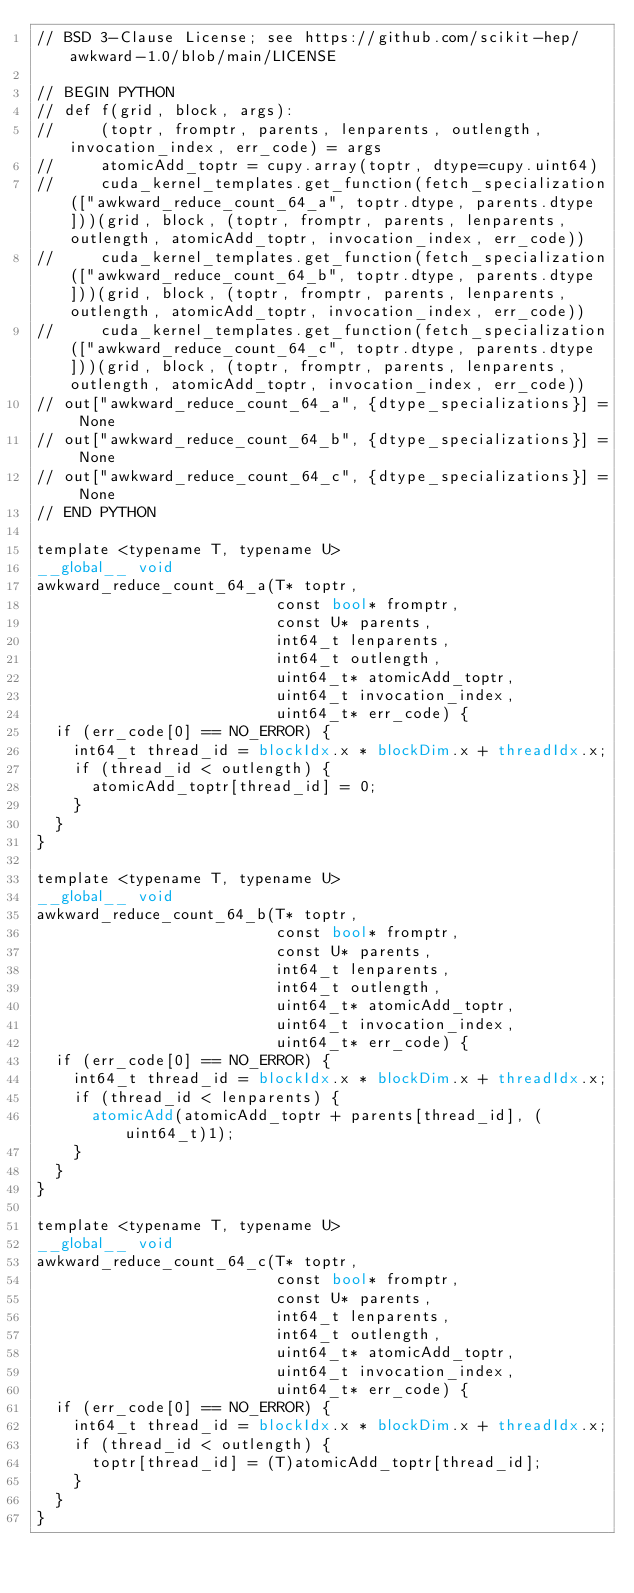Convert code to text. <code><loc_0><loc_0><loc_500><loc_500><_Cuda_>// BSD 3-Clause License; see https://github.com/scikit-hep/awkward-1.0/blob/main/LICENSE

// BEGIN PYTHON
// def f(grid, block, args):
//     (toptr, fromptr, parents, lenparents, outlength, invocation_index, err_code) = args
//     atomicAdd_toptr = cupy.array(toptr, dtype=cupy.uint64)
//     cuda_kernel_templates.get_function(fetch_specialization(["awkward_reduce_count_64_a", toptr.dtype, parents.dtype]))(grid, block, (toptr, fromptr, parents, lenparents, outlength, atomicAdd_toptr, invocation_index, err_code))
//     cuda_kernel_templates.get_function(fetch_specialization(["awkward_reduce_count_64_b", toptr.dtype, parents.dtype]))(grid, block, (toptr, fromptr, parents, lenparents, outlength, atomicAdd_toptr, invocation_index, err_code))
//     cuda_kernel_templates.get_function(fetch_specialization(["awkward_reduce_count_64_c", toptr.dtype, parents.dtype]))(grid, block, (toptr, fromptr, parents, lenparents, outlength, atomicAdd_toptr, invocation_index, err_code))
// out["awkward_reduce_count_64_a", {dtype_specializations}] = None
// out["awkward_reduce_count_64_b", {dtype_specializations}] = None
// out["awkward_reduce_count_64_c", {dtype_specializations}] = None
// END PYTHON

template <typename T, typename U>
__global__ void
awkward_reduce_count_64_a(T* toptr,
                          const bool* fromptr,
                          const U* parents,
                          int64_t lenparents,
                          int64_t outlength,
                          uint64_t* atomicAdd_toptr,
                          uint64_t invocation_index,
                          uint64_t* err_code) {
  if (err_code[0] == NO_ERROR) {
    int64_t thread_id = blockIdx.x * blockDim.x + threadIdx.x;
    if (thread_id < outlength) {
      atomicAdd_toptr[thread_id] = 0;
    }
  }
}

template <typename T, typename U>
__global__ void
awkward_reduce_count_64_b(T* toptr,
                          const bool* fromptr,
                          const U* parents,
                          int64_t lenparents,
                          int64_t outlength,
                          uint64_t* atomicAdd_toptr,
                          uint64_t invocation_index,
                          uint64_t* err_code) {
  if (err_code[0] == NO_ERROR) {
    int64_t thread_id = blockIdx.x * blockDim.x + threadIdx.x;
    if (thread_id < lenparents) {
      atomicAdd(atomicAdd_toptr + parents[thread_id], (uint64_t)1);
    }
  }
}

template <typename T, typename U>
__global__ void
awkward_reduce_count_64_c(T* toptr,
                          const bool* fromptr,
                          const U* parents,
                          int64_t lenparents,
                          int64_t outlength,
                          uint64_t* atomicAdd_toptr,
                          uint64_t invocation_index,
                          uint64_t* err_code) {
  if (err_code[0] == NO_ERROR) {
    int64_t thread_id = blockIdx.x * blockDim.x + threadIdx.x;
    if (thread_id < outlength) {
      toptr[thread_id] = (T)atomicAdd_toptr[thread_id];
    }
  }
}
</code> 